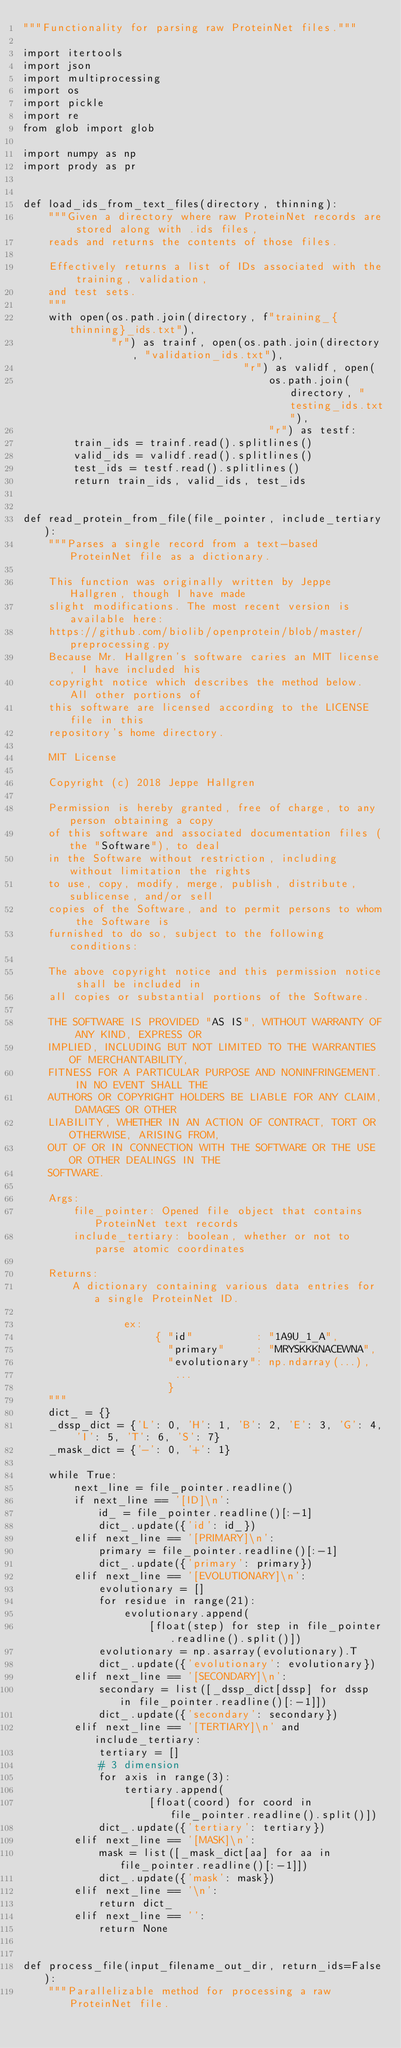<code> <loc_0><loc_0><loc_500><loc_500><_Python_>"""Functionality for parsing raw ProteinNet files."""

import itertools
import json
import multiprocessing
import os
import pickle
import re
from glob import glob

import numpy as np
import prody as pr


def load_ids_from_text_files(directory, thinning):
    """Given a directory where raw ProteinNet records are stored along with .ids files,
    reads and returns the contents of those files.

    Effectively returns a list of IDs associated with the training, validation,
    and test sets.
    """
    with open(os.path.join(directory, f"training_{thinning}_ids.txt"),
              "r") as trainf, open(os.path.join(directory, "validation_ids.txt"),
                                   "r") as validf, open(
                                       os.path.join(directory, "testing_ids.txt"),
                                       "r") as testf:
        train_ids = trainf.read().splitlines()
        valid_ids = validf.read().splitlines()
        test_ids = testf.read().splitlines()
        return train_ids, valid_ids, test_ids


def read_protein_from_file(file_pointer, include_tertiary):
    """Parses a single record from a text-based ProteinNet file as a dictionary.

    This function was originally written by Jeppe Hallgren, though I have made
    slight modifications. The most recent version is available here:
    https://github.com/biolib/openprotein/blob/master/preprocessing.py
    Because Mr. Hallgren's software caries an MIT license, I have included his
    copyright notice which describes the method below. All other portions of
    this software are licensed according to the LICENSE file in this
    repository's home directory.

    MIT License

    Copyright (c) 2018 Jeppe Hallgren

    Permission is hereby granted, free of charge, to any person obtaining a copy
    of this software and associated documentation files (the "Software"), to deal
    in the Software without restriction, including without limitation the rights
    to use, copy, modify, merge, publish, distribute, sublicense, and/or sell
    copies of the Software, and to permit persons to whom the Software is
    furnished to do so, subject to the following conditions:

    The above copyright notice and this permission notice shall be included in
    all copies or substantial portions of the Software.

    THE SOFTWARE IS PROVIDED "AS IS", WITHOUT WARRANTY OF ANY KIND, EXPRESS OR
    IMPLIED, INCLUDING BUT NOT LIMITED TO THE WARRANTIES OF MERCHANTABILITY,
    FITNESS FOR A PARTICULAR PURPOSE AND NONINFRINGEMENT. IN NO EVENT SHALL THE
    AUTHORS OR COPYRIGHT HOLDERS BE LIABLE FOR ANY CLAIM, DAMAGES OR OTHER
    LIABILITY, WHETHER IN AN ACTION OF CONTRACT, TORT OR OTHERWISE, ARISING FROM,
    OUT OF OR IN CONNECTION WITH THE SOFTWARE OR THE USE OR OTHER DEALINGS IN THE
    SOFTWARE.

    Args:
        file_pointer: Opened file object that contains ProteinNet text records
        include_tertiary: boolean, whether or not to parse atomic coordinates

    Returns:
        A dictionary containing various data entries for a single ProteinNet ID.

                ex:
                     { "id"          : "1A9U_1_A",
                       "primary"     : "MRYSKKKNACEWNA",
                       "evolutionary": np.ndarray(...),
                        ...
                       }
    """
    dict_ = {}
    _dssp_dict = {'L': 0, 'H': 1, 'B': 2, 'E': 3, 'G': 4, 'I': 5, 'T': 6, 'S': 7}
    _mask_dict = {'-': 0, '+': 1}

    while True:
        next_line = file_pointer.readline()
        if next_line == '[ID]\n':
            id_ = file_pointer.readline()[:-1]
            dict_.update({'id': id_})
        elif next_line == '[PRIMARY]\n':
            primary = file_pointer.readline()[:-1]
            dict_.update({'primary': primary})
        elif next_line == '[EVOLUTIONARY]\n':
            evolutionary = []
            for residue in range(21):
                evolutionary.append(
                    [float(step) for step in file_pointer.readline().split()])
            evolutionary = np.asarray(evolutionary).T
            dict_.update({'evolutionary': evolutionary})
        elif next_line == '[SECONDARY]\n':
            secondary = list([_dssp_dict[dssp] for dssp in file_pointer.readline()[:-1]])
            dict_.update({'secondary': secondary})
        elif next_line == '[TERTIARY]\n' and include_tertiary:
            tertiary = []
            # 3 dimension
            for axis in range(3):
                tertiary.append(
                    [float(coord) for coord in file_pointer.readline().split()])
            dict_.update({'tertiary': tertiary})
        elif next_line == '[MASK]\n':
            mask = list([_mask_dict[aa] for aa in file_pointer.readline()[:-1]])
            dict_.update({'mask': mask})
        elif next_line == '\n':
            return dict_
        elif next_line == '':
            return None


def process_file(input_filename_out_dir, return_ids=False):
    """Parallelizable method for processing a raw ProteinNet file.
</code> 